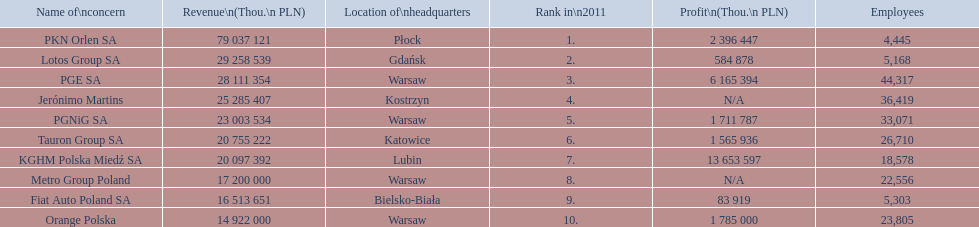What is the number of employees that work for pkn orlen sa in poland? 4,445. What number of employees work for lotos group sa? 5,168. How many people work for pgnig sa? 33,071. 